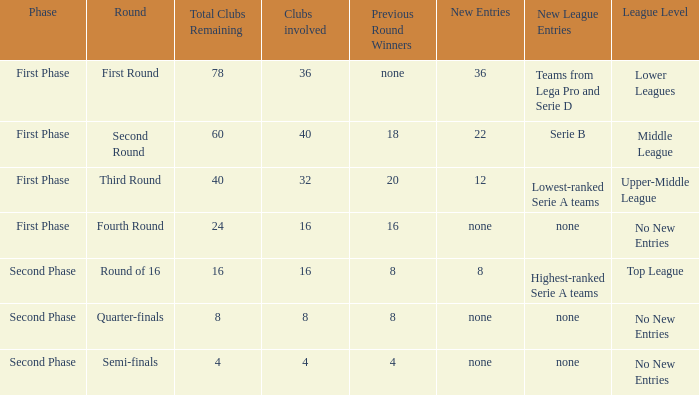With 8 clubs participating, what quantity can be determined from victors in the prior round? 8.0. 